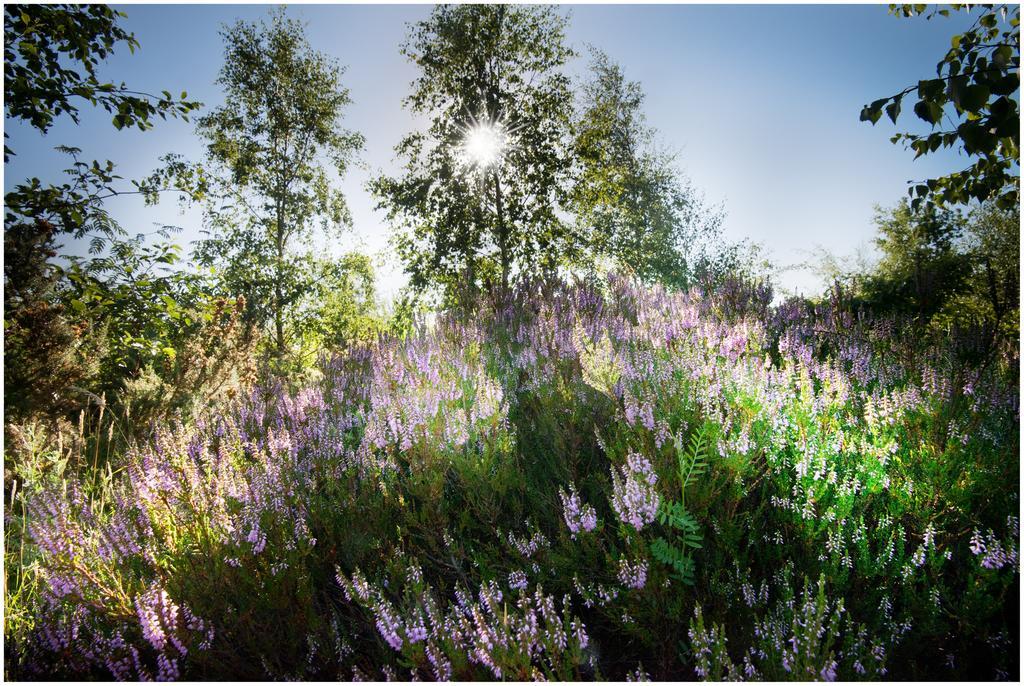Can you describe this image briefly? In the picture there are beautiful plants with purple flowers and around them there are some other trees and there is a bright sunshine from middle of one of the tree. 